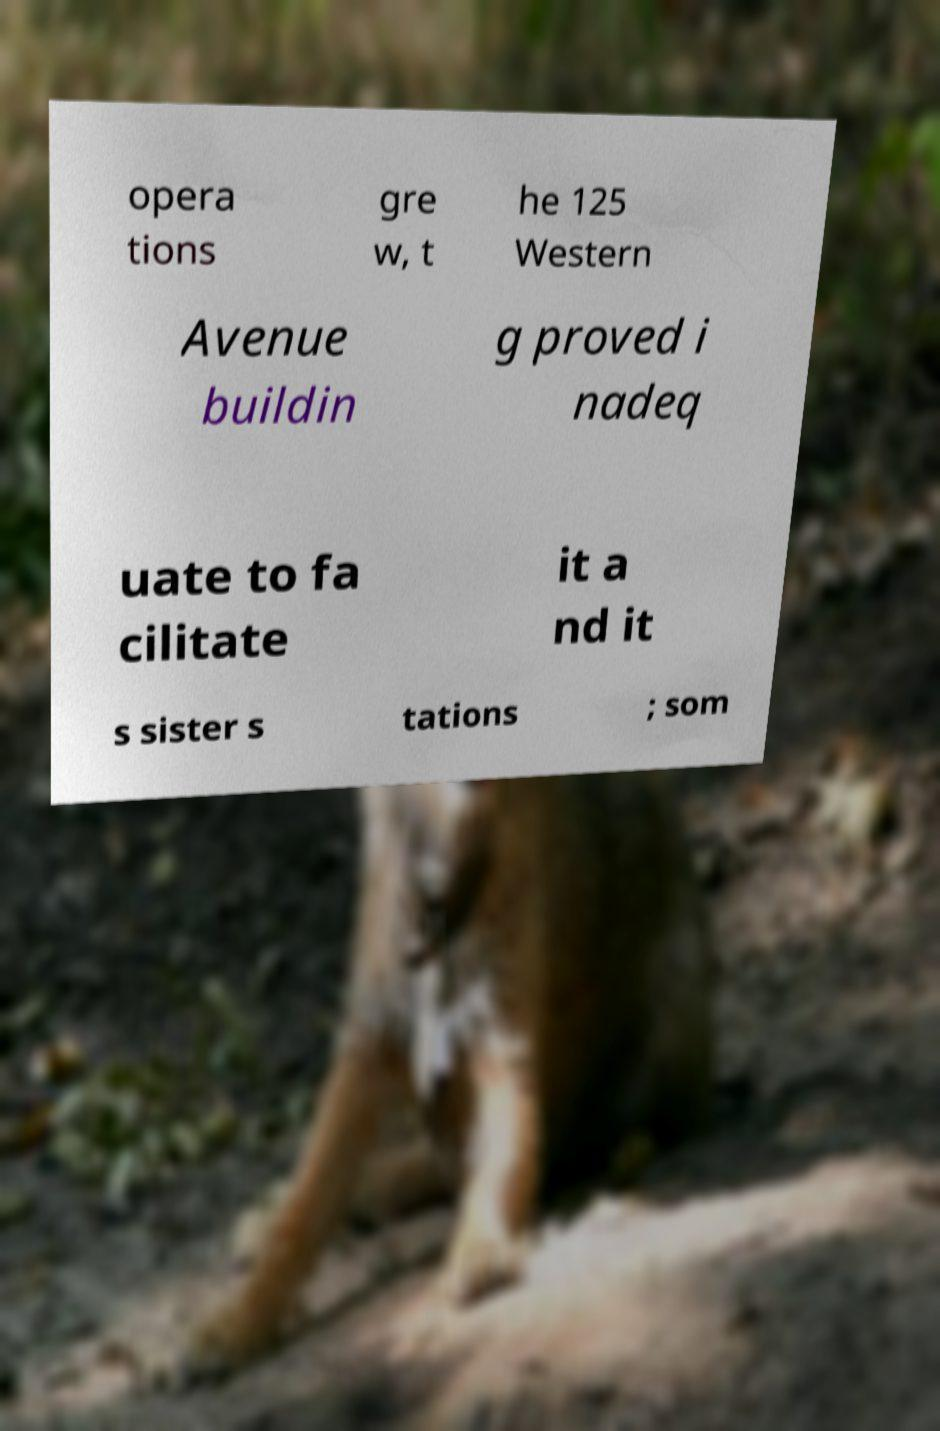Could you assist in decoding the text presented in this image and type it out clearly? opera tions gre w, t he 125 Western Avenue buildin g proved i nadeq uate to fa cilitate it a nd it s sister s tations ; som 